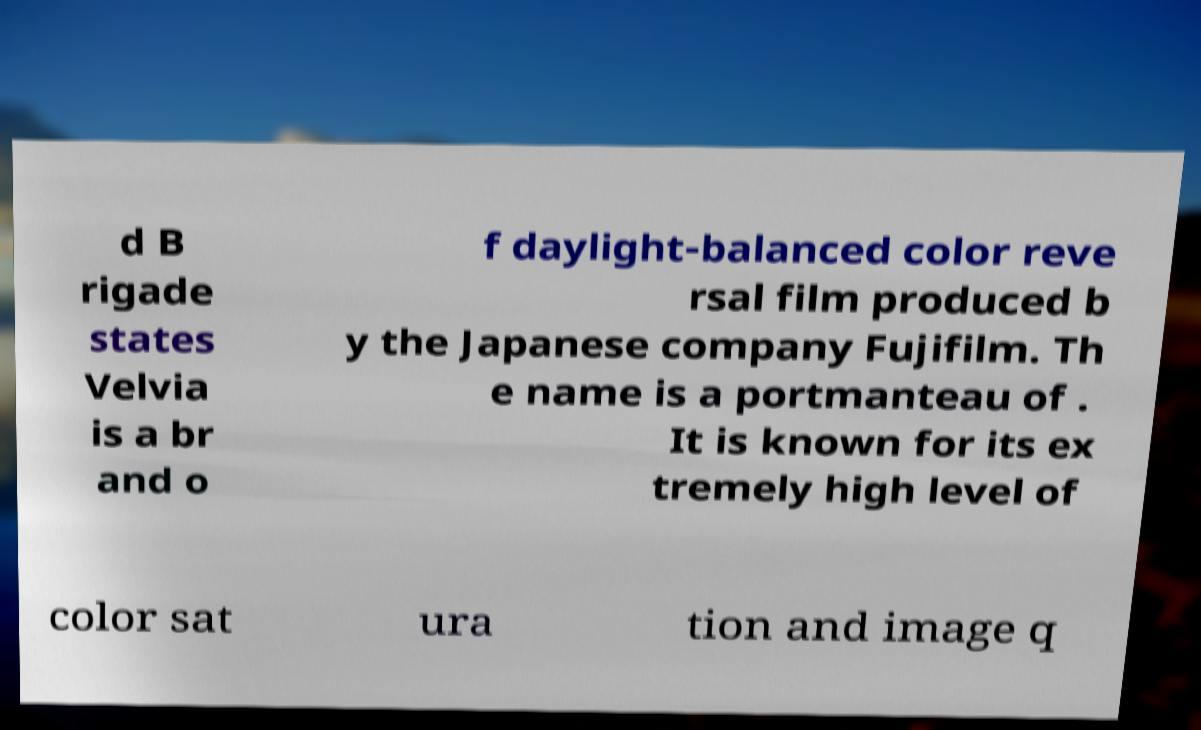Please identify and transcribe the text found in this image. d B rigade states Velvia is a br and o f daylight-balanced color reve rsal film produced b y the Japanese company Fujifilm. Th e name is a portmanteau of . It is known for its ex tremely high level of color sat ura tion and image q 